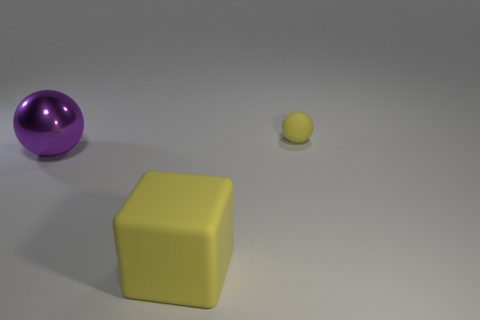Add 3 small matte cylinders. How many objects exist? 6 Subtract all cubes. How many objects are left? 2 Add 3 gray matte blocks. How many gray matte blocks exist? 3 Subtract 0 cyan cubes. How many objects are left? 3 Subtract all shiny spheres. Subtract all large rubber objects. How many objects are left? 1 Add 1 metallic balls. How many metallic balls are left? 2 